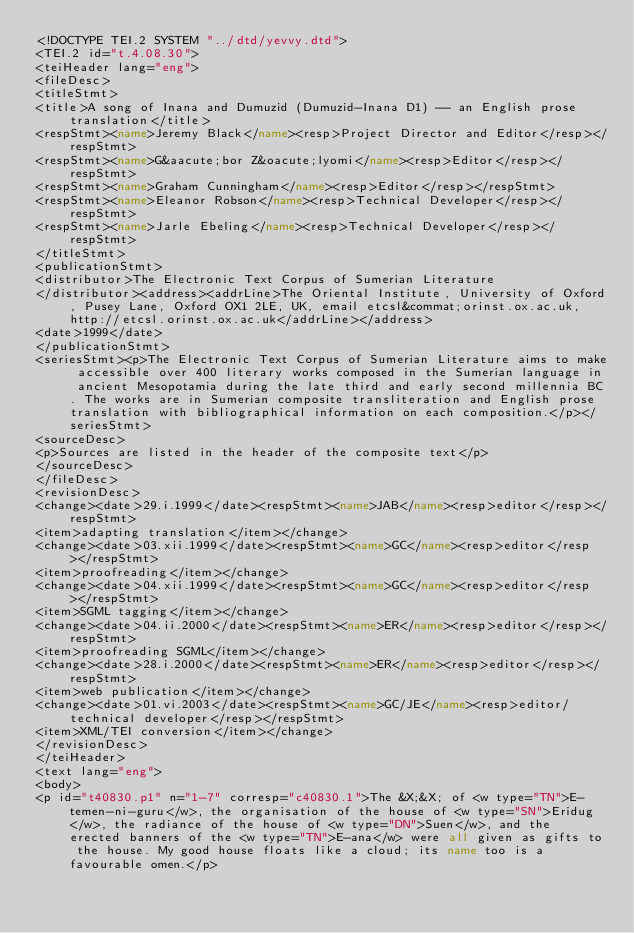Convert code to text. <code><loc_0><loc_0><loc_500><loc_500><_XML_><!DOCTYPE TEI.2 SYSTEM "../dtd/yevvy.dtd">
<TEI.2 id="t.4.08.30">
<teiHeader lang="eng">
<fileDesc>
<titleStmt>
<title>A song of Inana and Dumuzid (Dumuzid-Inana D1) -- an English prose translation</title>
<respStmt><name>Jeremy Black</name><resp>Project Director and Editor</resp></respStmt>
<respStmt><name>G&aacute;bor Z&oacute;lyomi</name><resp>Editor</resp></respStmt>
<respStmt><name>Graham Cunningham</name><resp>Editor</resp></respStmt>
<respStmt><name>Eleanor Robson</name><resp>Technical Developer</resp></respStmt>
<respStmt><name>Jarle Ebeling</name><resp>Technical Developer</resp></respStmt>
</titleStmt>
<publicationStmt>
<distributor>The Electronic Text Corpus of Sumerian Literature
</distributor><address><addrLine>The Oriental Institute, University of Oxford, Pusey Lane, Oxford OX1 2LE, UK, email etcsl&commat;orinst.ox.ac.uk, http://etcsl.orinst.ox.ac.uk</addrLine></address>
<date>1999</date>
</publicationStmt>
<seriesStmt><p>The Electronic Text Corpus of Sumerian Literature aims to make accessible over 400 literary works composed in the Sumerian language in ancient Mesopotamia during the late third and early second millennia BC. The works are in Sumerian composite transliteration and English prose translation with bibliographical information on each composition.</p></seriesStmt>
<sourceDesc>
<p>Sources are listed in the header of the composite text</p>
</sourceDesc>
</fileDesc>
<revisionDesc>
<change><date>29.i.1999</date><respStmt><name>JAB</name><resp>editor</resp></respStmt>
<item>adapting translation</item></change>
<change><date>03.xii.1999</date><respStmt><name>GC</name><resp>editor</resp></respStmt>
<item>proofreading</item></change>
<change><date>04.xii.1999</date><respStmt><name>GC</name><resp>editor</resp></respStmt>
<item>SGML tagging</item></change>
<change><date>04.ii.2000</date><respStmt><name>ER</name><resp>editor</resp></respStmt>
<item>proofreading SGML</item></change>
<change><date>28.i.2000</date><respStmt><name>ER</name><resp>editor</resp></respStmt>
<item>web publication</item></change>
<change><date>01.vi.2003</date><respStmt><name>GC/JE</name><resp>editor/technical developer</resp></respStmt>
<item>XML/TEI conversion</item></change>
</revisionDesc>
</teiHeader>
<text lang="eng">
<body>
<p id="t40830.p1" n="1-7" corresp="c40830.1">The &X;&X; of <w type="TN">E-temen-ni-guru</w>, the organisation of the house of <w type="SN">Eridug</w>, the radiance of the house of <w type="DN">Suen</w>, and the erected banners of the <w type="TN">E-ana</w> were all given as gifts to the house. My good house floats like a cloud; its name too is a favourable omen.</p></code> 